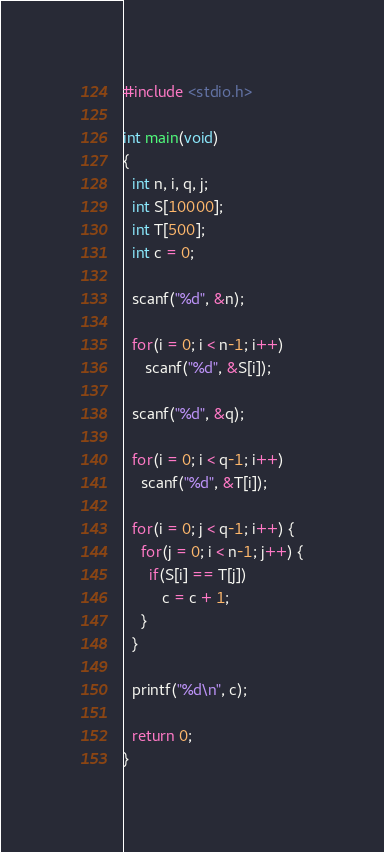<code> <loc_0><loc_0><loc_500><loc_500><_C_>#include <stdio.h>

int main(void)
{
  int n, i, q, j;
  int S[10000];
  int T[500];
  int c = 0;

  scanf("%d", &n);

  for(i = 0; i < n-1; i++)
     scanf("%d", &S[i]);

  scanf("%d", &q);

  for(i = 0; i < q-1; i++)
    scanf("%d", &T[i]);

  for(i = 0; j < q-1; i++) {
    for(j = 0; i < n-1; j++) {
      if(S[i] == T[j])
         c = c + 1;
    }
  }

  printf("%d\n", c);

  return 0;
}</code> 